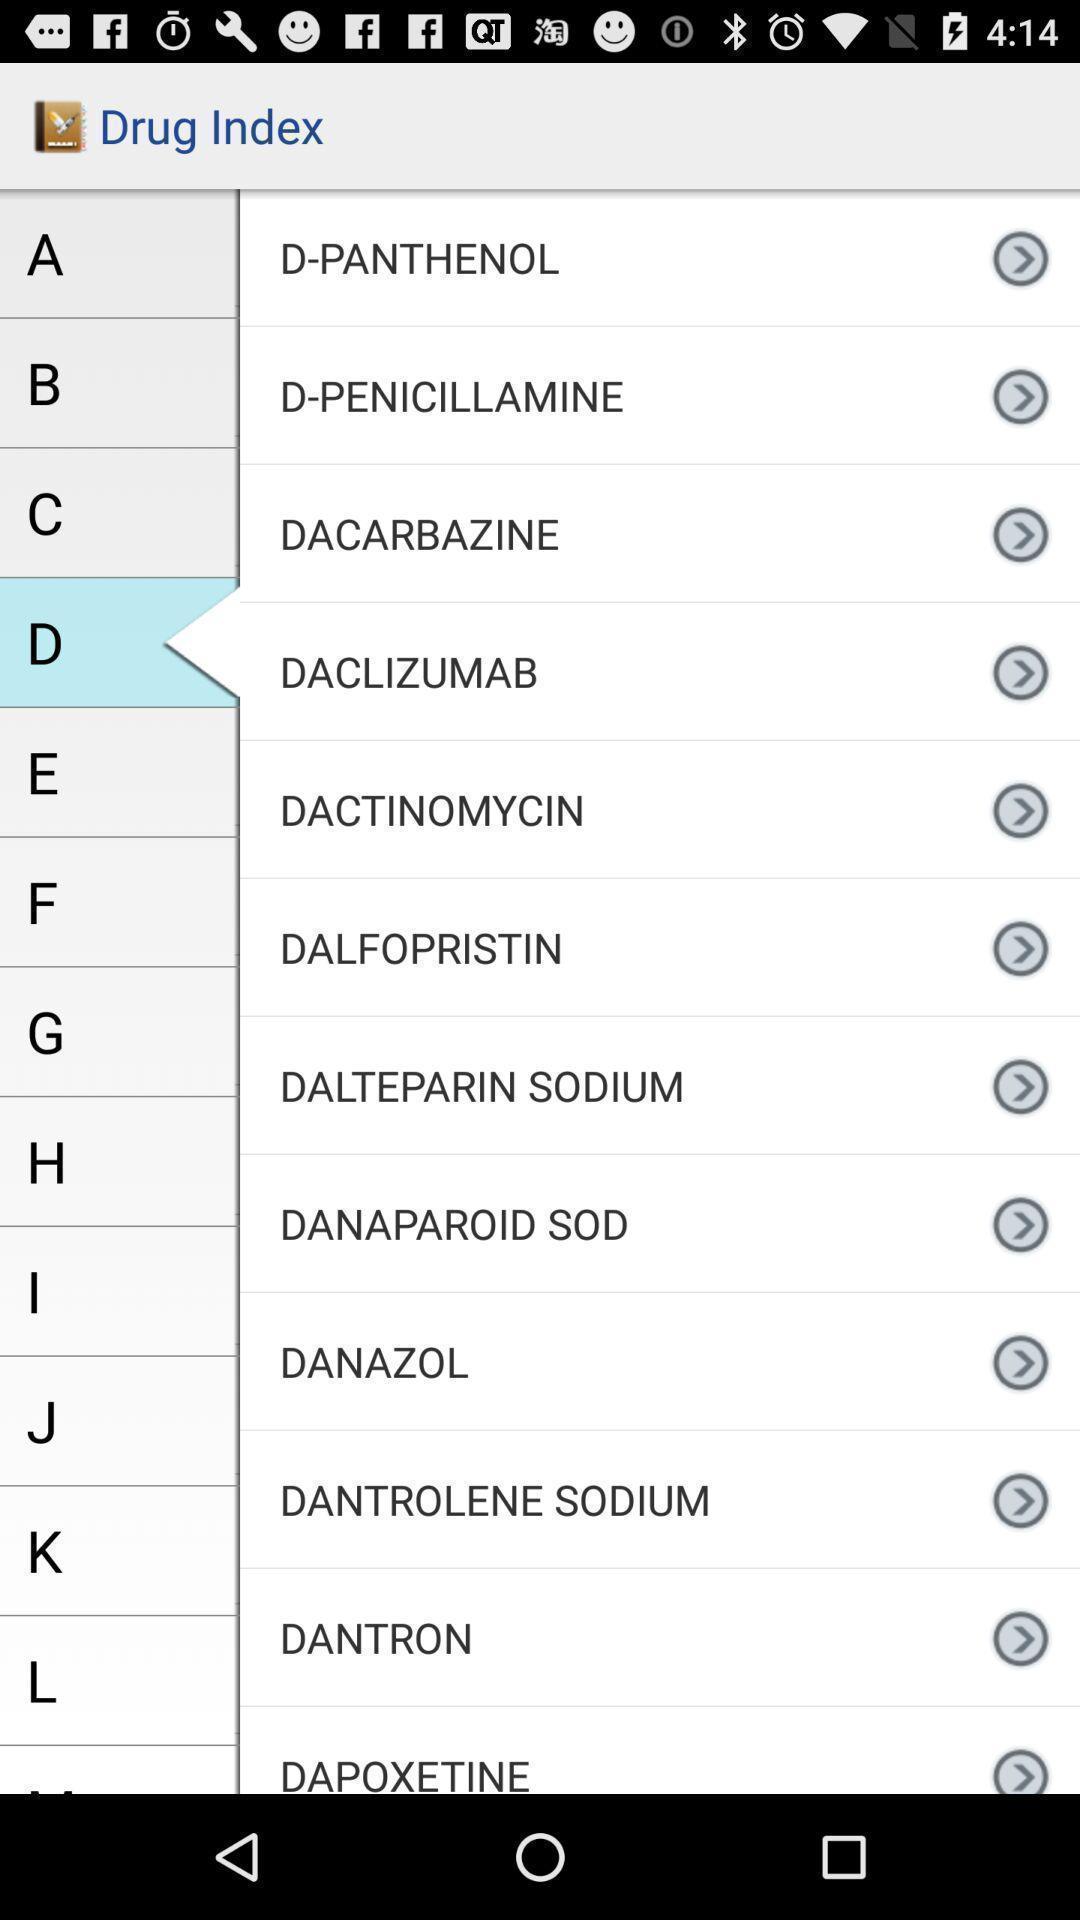Describe the visual elements of this screenshot. Screen displaying a list drug names in alphabetical order. 